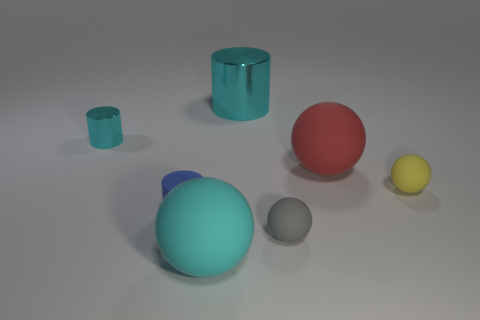Could you guess the purpose of these objects? These objects appear to be part of a visual composition or render, possibly meant for demonstrating shapes, colors, and materials in a controlled lighting environment. They do not seem to have a specific function beyond visual or educational purposes. 